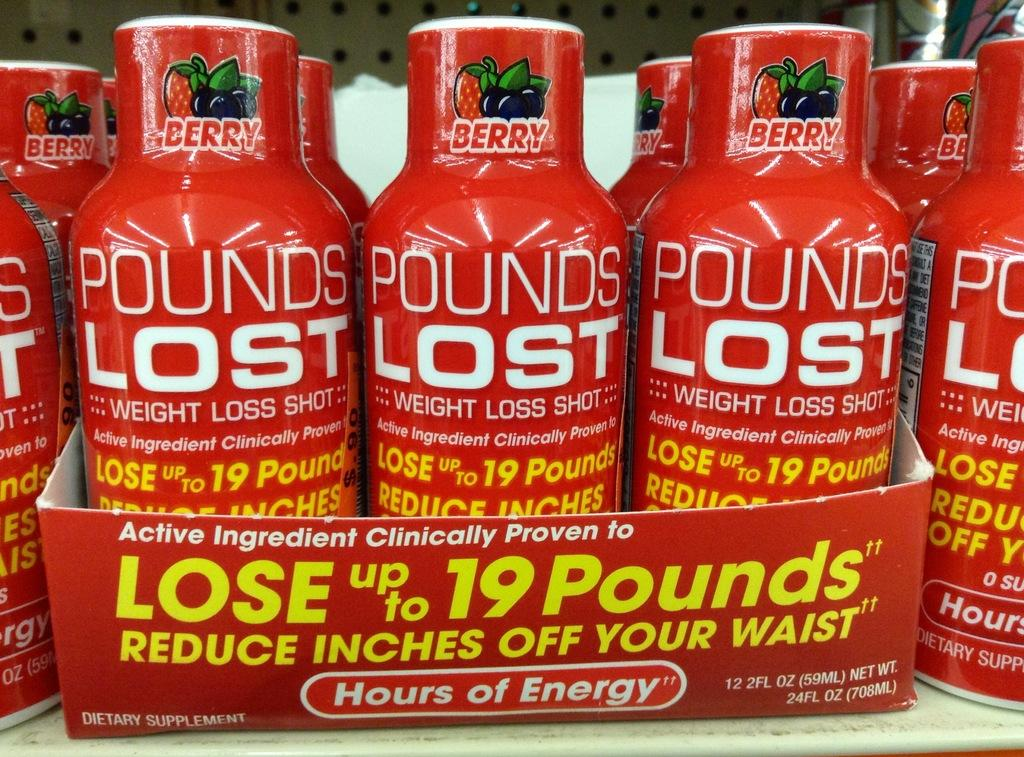<image>
Offer a succinct explanation of the picture presented. Red bottles have pounds lost and the flavor of berry. 